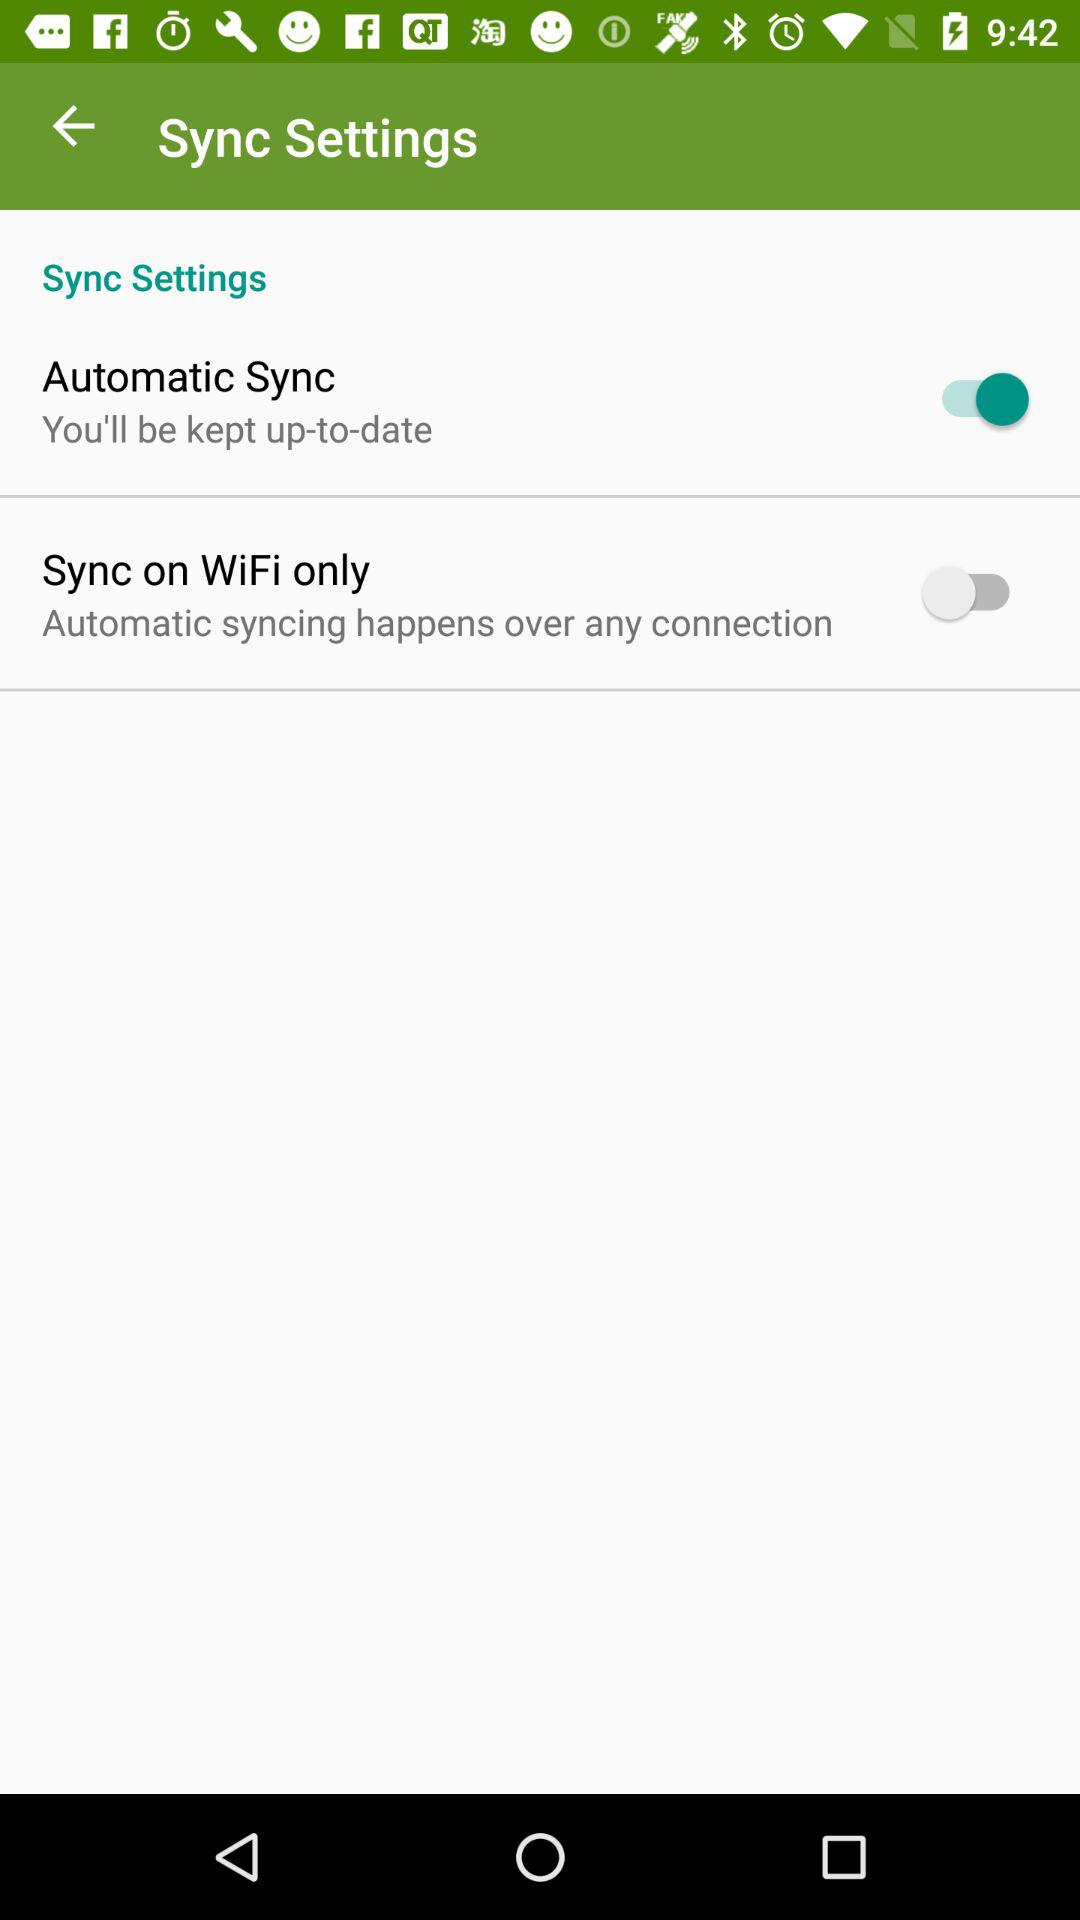How many options are there for syncing?
Answer the question using a single word or phrase. 2 